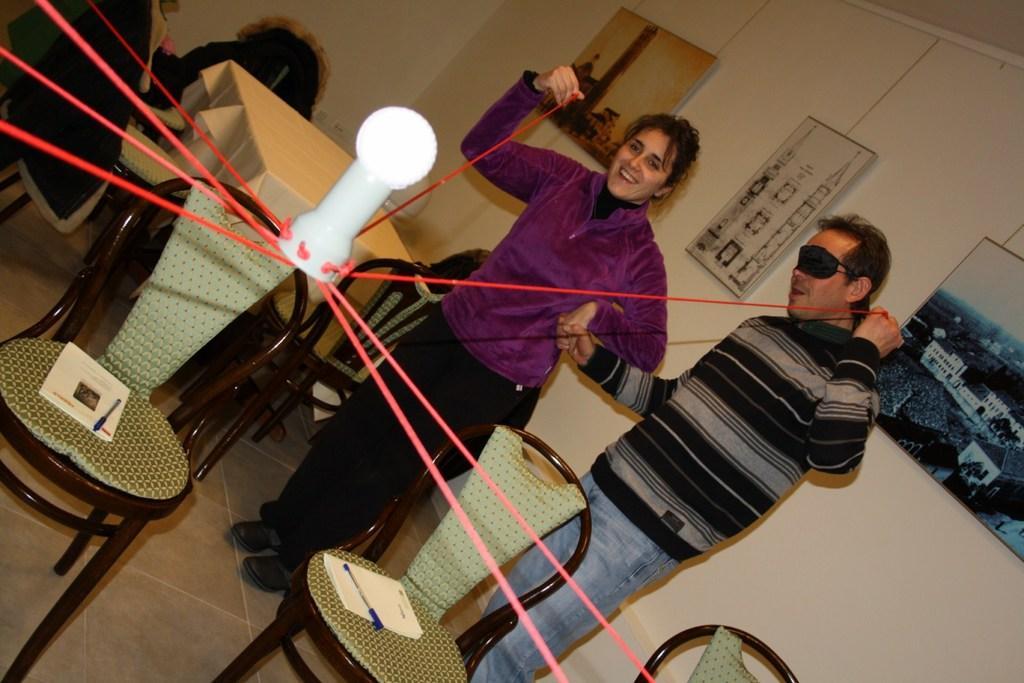How would you summarize this image in a sentence or two? In the center of the image there is a light and there are people holding it with the thread. There are chairs. On top of it there are books and pens. At the bottom of the image there is a floor. There is a table and there is cloth on it. In the background of the image there are photo frames attached to the wall. 